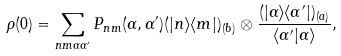Convert formula to latex. <formula><loc_0><loc_0><loc_500><loc_500>\rho ( 0 ) = \sum _ { n m \alpha \alpha ^ { \prime } } P _ { n m } ( \alpha , \alpha ^ { \prime } ) ( | n \rangle \langle m | ) _ { ( b ) } \otimes \frac { ( | \alpha \rangle \langle \alpha ^ { \prime } | ) _ { ( a ) } } { \langle \alpha ^ { \prime } | \alpha \rangle } ,</formula> 